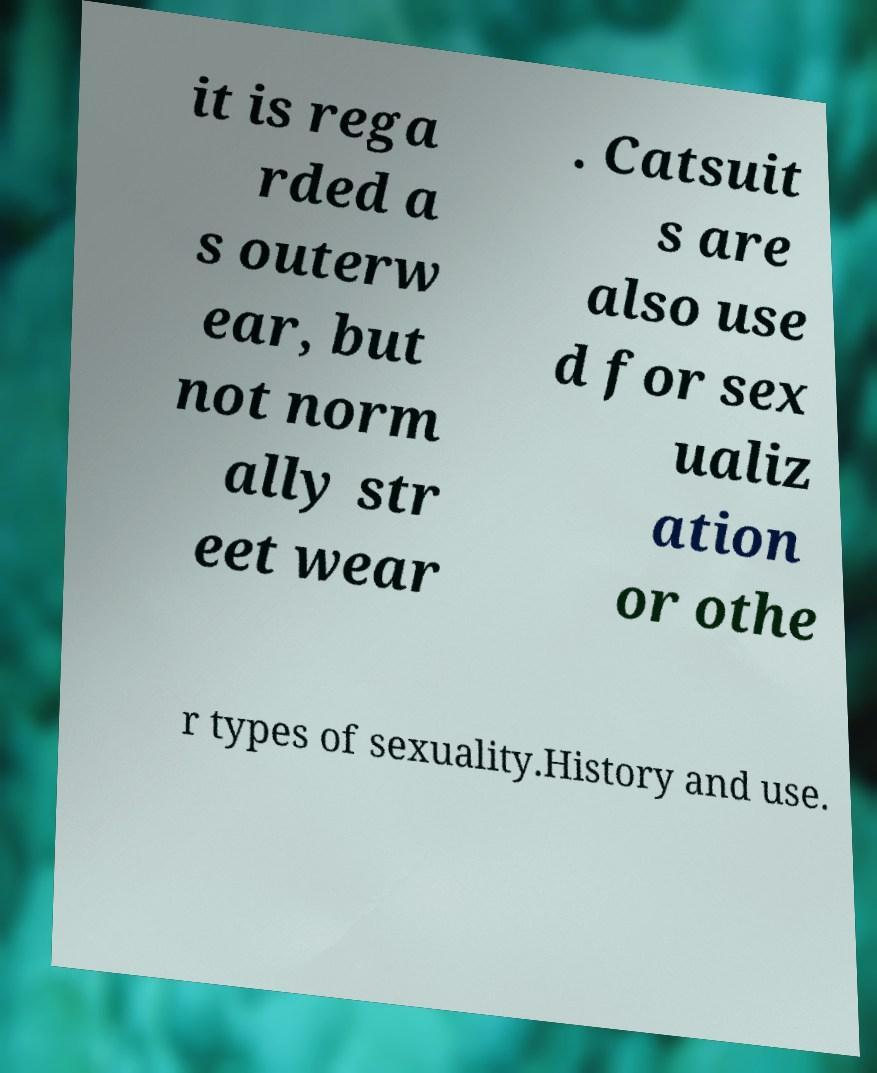For documentation purposes, I need the text within this image transcribed. Could you provide that? it is rega rded a s outerw ear, but not norm ally str eet wear . Catsuit s are also use d for sex ualiz ation or othe r types of sexuality.History and use. 